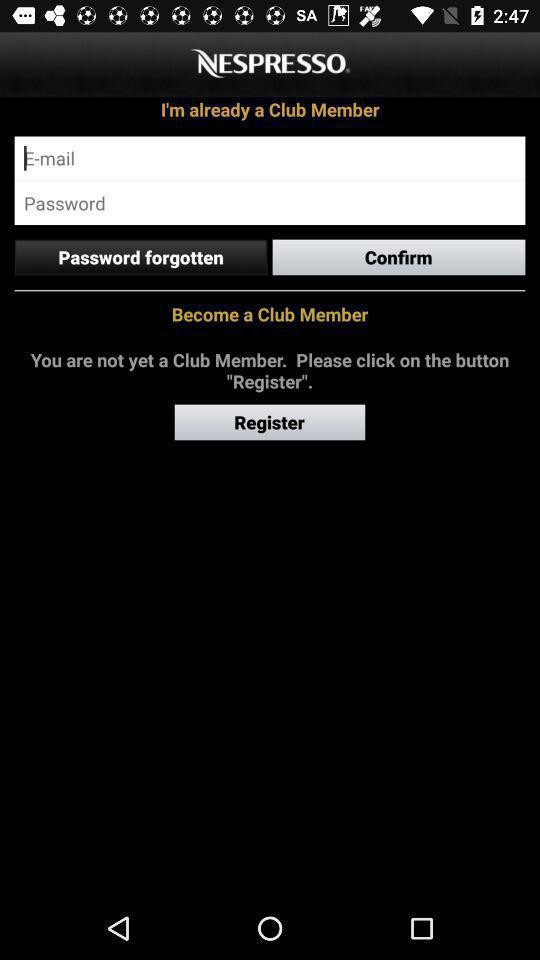What is the name of the application? The name of the application is "NESPRESSO". 